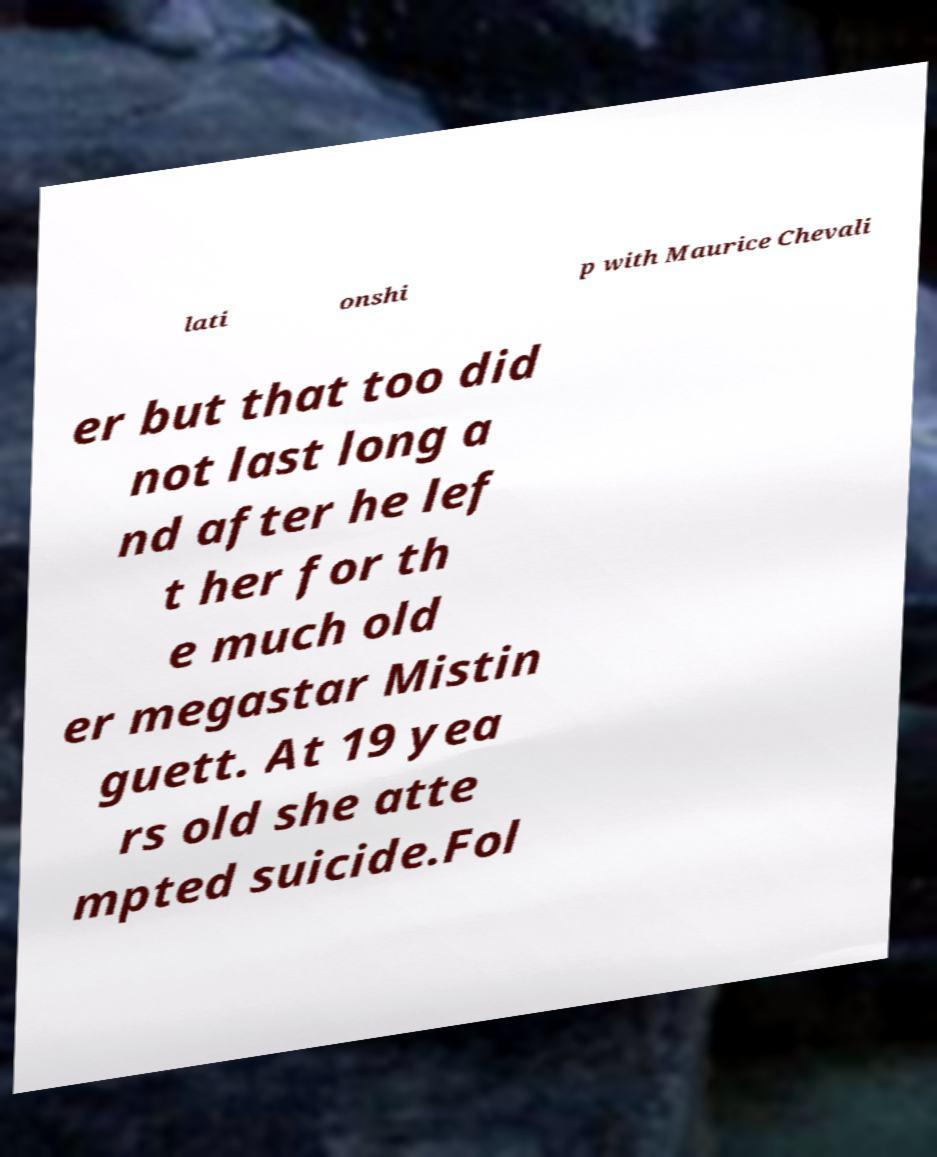Could you assist in decoding the text presented in this image and type it out clearly? lati onshi p with Maurice Chevali er but that too did not last long a nd after he lef t her for th e much old er megastar Mistin guett. At 19 yea rs old she atte mpted suicide.Fol 